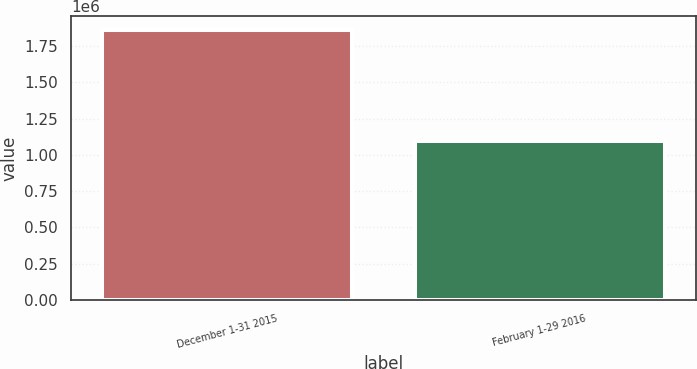Convert chart. <chart><loc_0><loc_0><loc_500><loc_500><bar_chart><fcel>December 1-31 2015<fcel>February 1-29 2016<nl><fcel>1.86508e+06<fcel>1.0989e+06<nl></chart> 